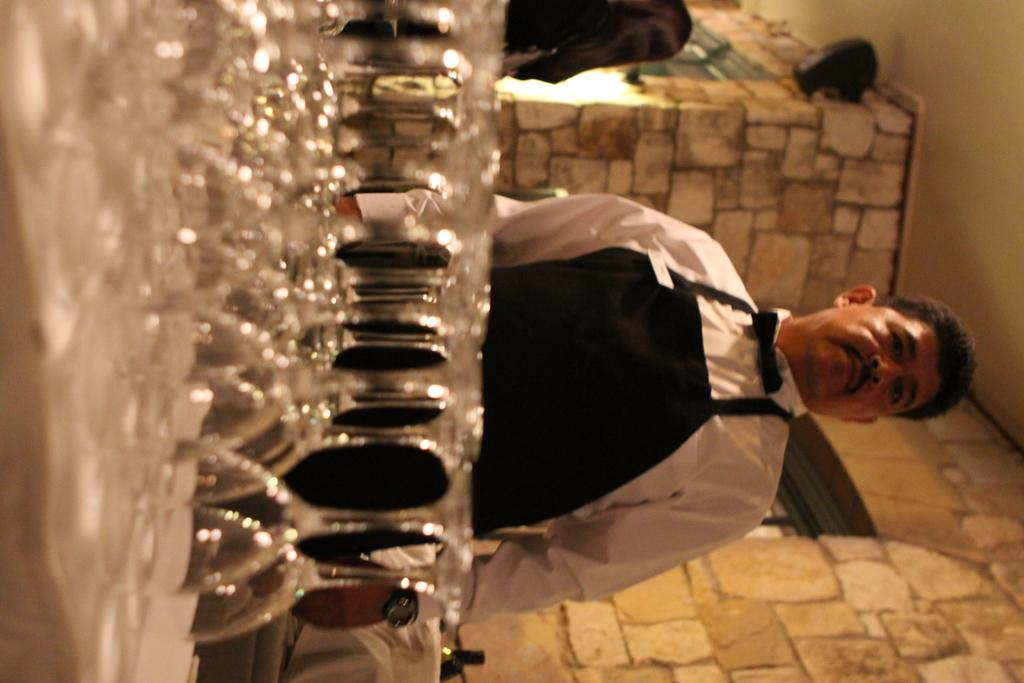What objects can be seen in the image? There are glasses in the image. Who is present in the image? There is a man in the image. What is the man wearing? The man is wearing a white and black dress. What can be seen behind the man in the image? There is a wall in the image. What is above the man in the image? There is a ceiling in the image. What type of mint is growing on the ceiling in the image? There is no mint growing on the ceiling in the image; it is a plain ceiling. 